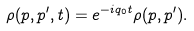Convert formula to latex. <formula><loc_0><loc_0><loc_500><loc_500>\rho ( p , p ^ { \prime } , t ) = e ^ { - i q _ { 0 } t } \rho ( p , p ^ { \prime } ) .</formula> 